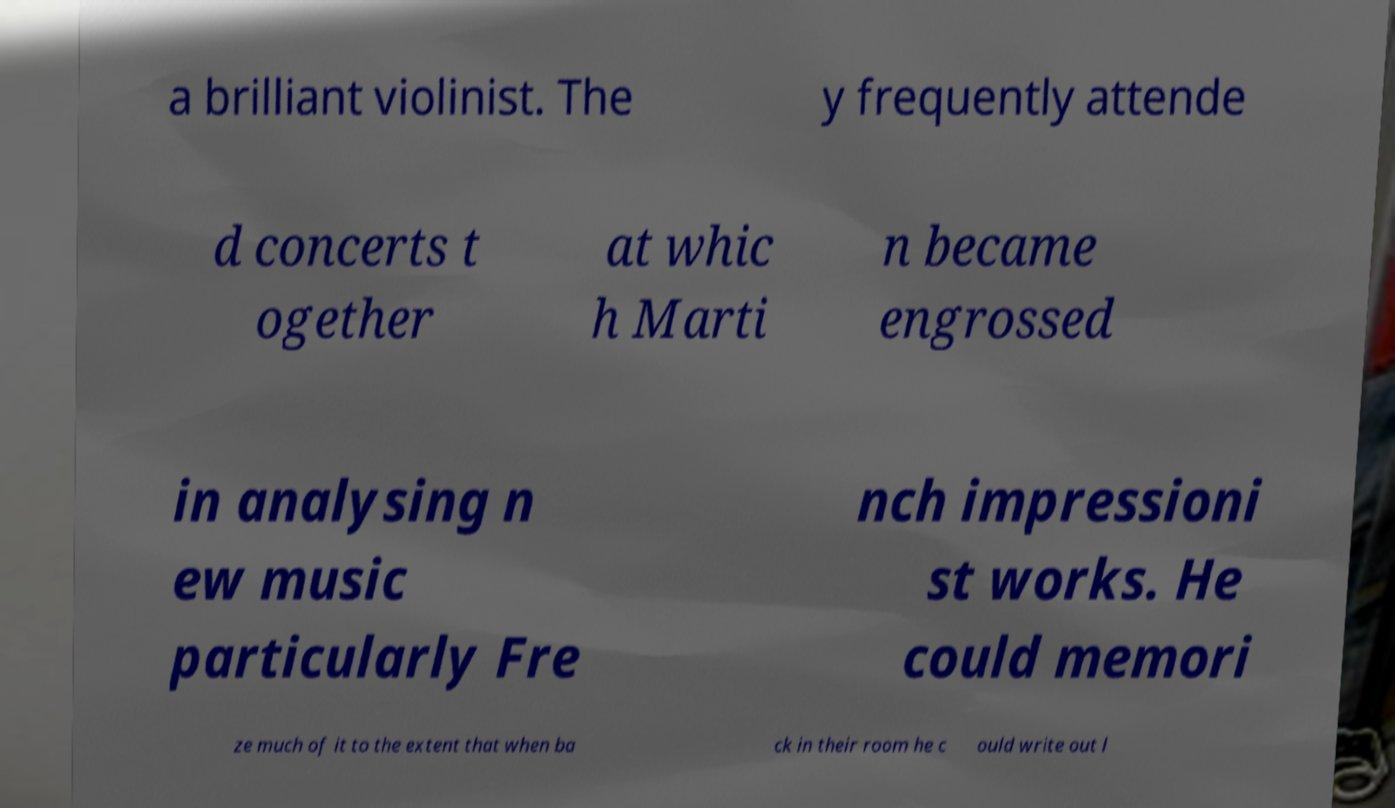Please identify and transcribe the text found in this image. a brilliant violinist. The y frequently attende d concerts t ogether at whic h Marti n became engrossed in analysing n ew music particularly Fre nch impressioni st works. He could memori ze much of it to the extent that when ba ck in their room he c ould write out l 